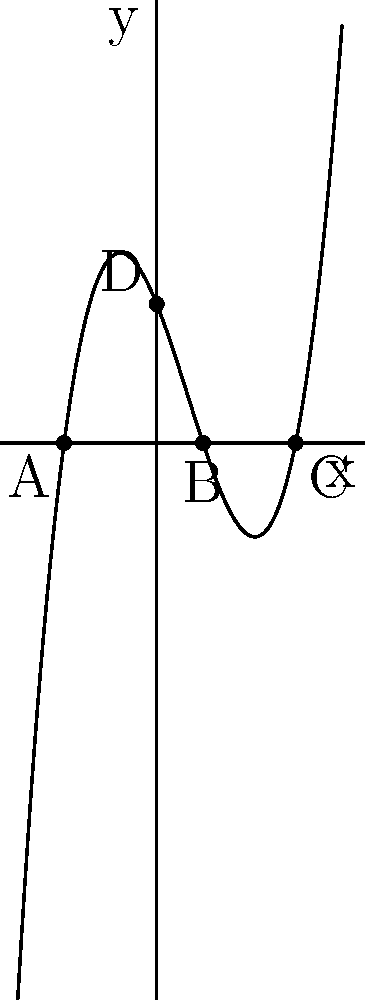The graph above represents a cubic polynomial function. Points A, B, and C are the roots of the polynomial, while point D represents the y-intercept. If this function were to model the varying levels of comfort experienced by women wearing niqabs throughout the day (with x representing hours since sunrise), what would be the sum of the x-coordinates of all the roots? To solve this problem, we need to identify the x-coordinates of the roots (points A, B, and C) and add them together. Let's go through this step-by-step:

1. Identify the roots:
   - Point A: x-coordinate is -2
   - Point B: x-coordinate is 1
   - Point C: x-coordinate is 3

2. Sum the x-coordinates:
   $$ -2 + 1 + 3 = 2 $$

The sum of the x-coordinates of all the roots is 2.

In the context of the persona, this could represent that over a 24-hour period, there are three distinct times when comfort levels are neutral (neither comfortable nor uncomfortable). The sum of these times (2 hours after sunrise) might indicate a brief period of overall neutrality in the wearing experience throughout the day.
Answer: 2 